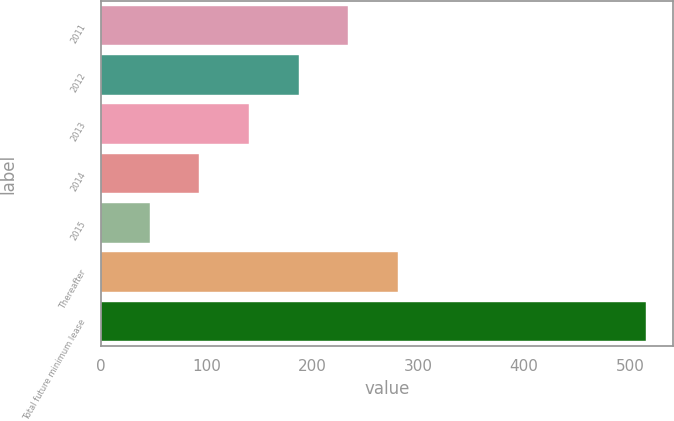Convert chart to OTSL. <chart><loc_0><loc_0><loc_500><loc_500><bar_chart><fcel>2011<fcel>2012<fcel>2013<fcel>2014<fcel>2015<fcel>Thereafter<fcel>Total future minimum lease<nl><fcel>233.6<fcel>186.7<fcel>139.8<fcel>92.9<fcel>46<fcel>280.5<fcel>515<nl></chart> 